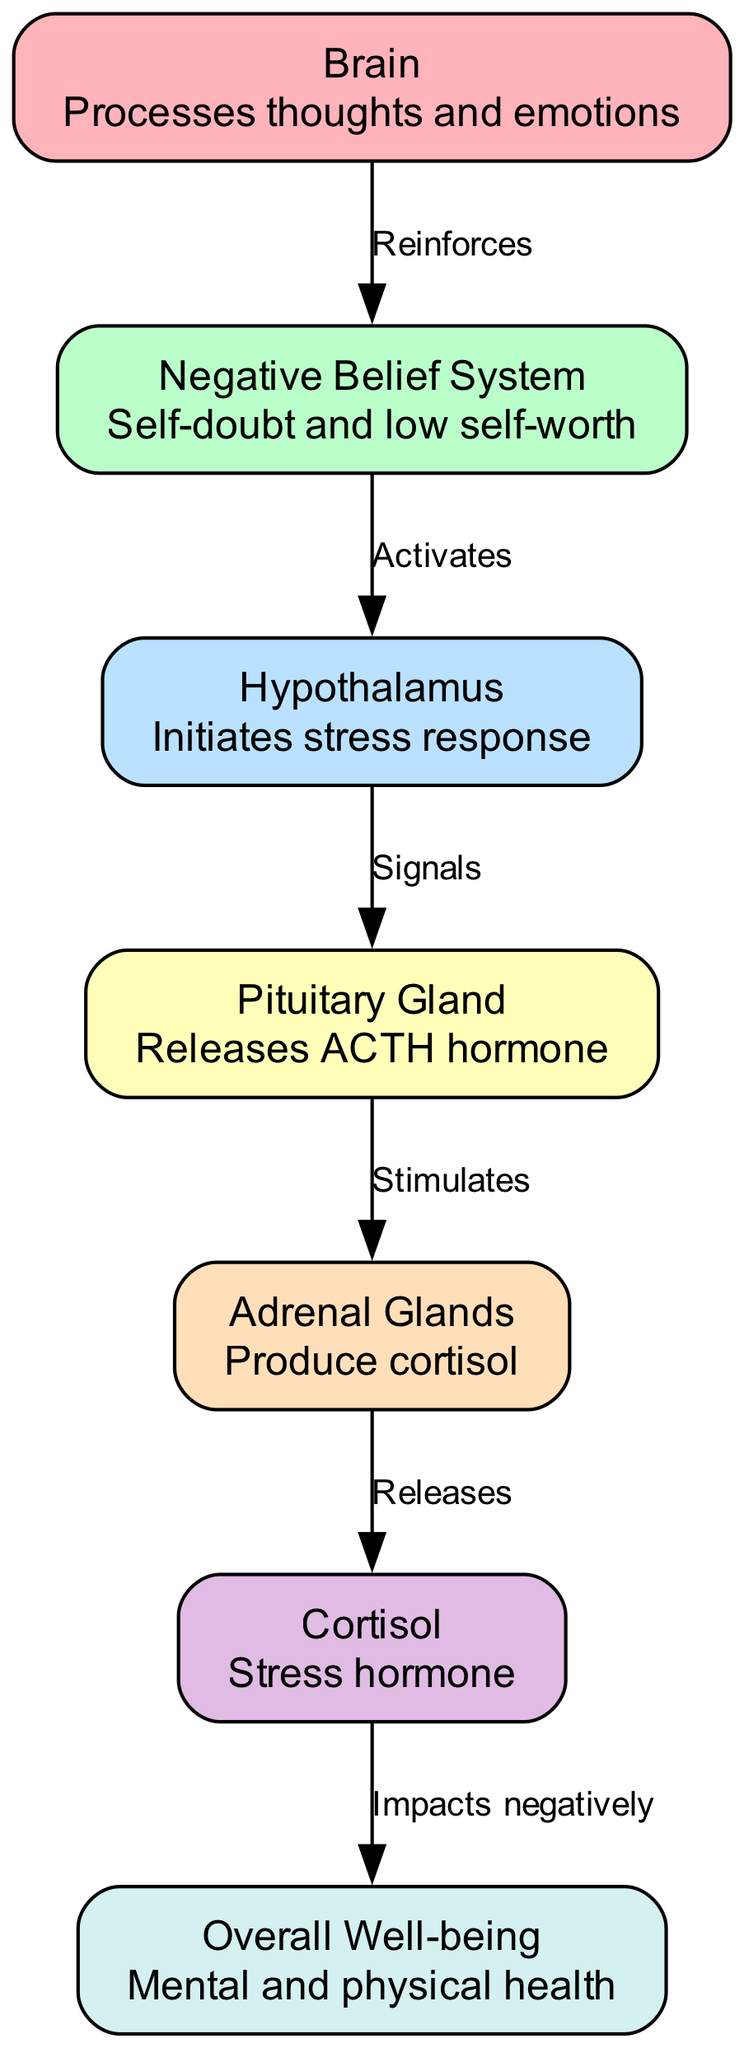What is the first node in the stress response system? The diagram lists "Brain" as the first node, which starts the flow of information and processes thoughts and emotions related to stress response.
Answer: Brain How many nodes are in the diagram? By counting the listed nodes, we find a total of seven nodes depicted in the diagram, representing various parts of the stress response system.
Answer: 7 What relationship is indicated between the negative belief system and the hypothalamus? The diagram shows that the "Negative Belief System" activates the "Hypothalamus," indicating a direct influence of negative beliefs on the activation of the stress response.
Answer: Activates What hormone is released by the pituitary gland? The pituitary gland in the diagram is labeled as releasing the ACTH hormone, which is significant in the stress response system.
Answer: ACTH How does cortisol impact overall well-being according to the diagram? The diagram indicates that cortisol impacts overall well-being negatively, highlighting how stress and negative beliefs can deteriorate mental health.
Answer: Impacts negatively What is the effect of the brain on negative belief systems? According to the diagram, the "Brain" reinforces negative belief systems, creating a feedback loop that can exacerbate self-doubt and low self-worth.
Answer: Reinforces Trace the flow from the adrenal glands to overall well-being. What is the key outcome? The flow indicates that after the adrenal glands release cortisol, this hormone has a direct negative impact on overall well-being, representing the physiological consequences of stress.
Answer: Negative impact Which component initiates the stress response in this diagram? The "Hypothalamus" is identified in the diagram as the component that initiates the stress response when activated, acting as a crucial mediator in the chain.
Answer: Hypothalamus What do the adrenal glands produce related to the stress response system? The diagram specifies that the adrenal glands produce cortisol, an essential stress hormone impacting various bodily functions during stress.
Answer: Cortisol 